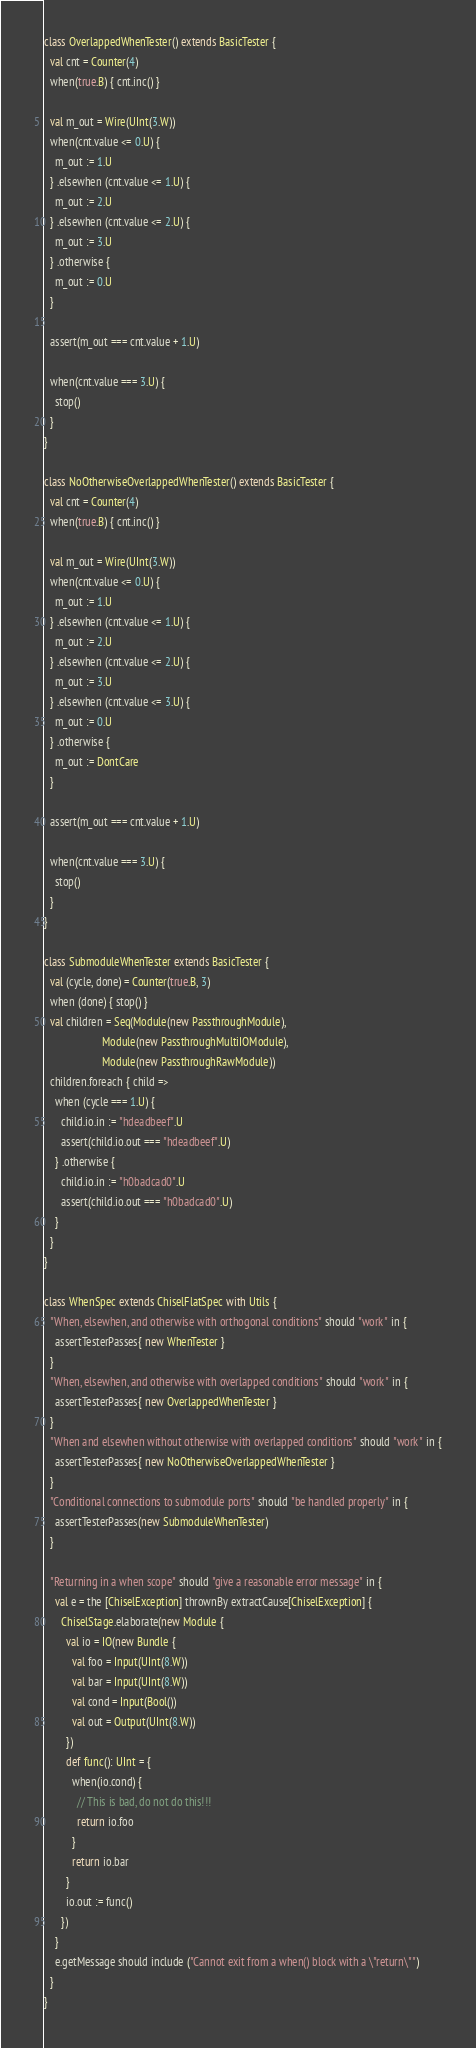Convert code to text. <code><loc_0><loc_0><loc_500><loc_500><_Scala_>
class OverlappedWhenTester() extends BasicTester {
  val cnt = Counter(4)
  when(true.B) { cnt.inc() }

  val m_out = Wire(UInt(3.W))
  when(cnt.value <= 0.U) {
    m_out := 1.U
  } .elsewhen (cnt.value <= 1.U) {
    m_out := 2.U
  } .elsewhen (cnt.value <= 2.U) {
    m_out := 3.U
  } .otherwise {
    m_out := 0.U
  }

  assert(m_out === cnt.value + 1.U)

  when(cnt.value === 3.U) {
    stop()
  }
}

class NoOtherwiseOverlappedWhenTester() extends BasicTester {
  val cnt = Counter(4)
  when(true.B) { cnt.inc() }

  val m_out = Wire(UInt(3.W))
  when(cnt.value <= 0.U) {
    m_out := 1.U
  } .elsewhen (cnt.value <= 1.U) {
    m_out := 2.U
  } .elsewhen (cnt.value <= 2.U) {
    m_out := 3.U
  } .elsewhen (cnt.value <= 3.U) {
    m_out := 0.U
  } .otherwise {
    m_out := DontCare
  }

  assert(m_out === cnt.value + 1.U)

  when(cnt.value === 3.U) {
    stop()
  }
}

class SubmoduleWhenTester extends BasicTester {
  val (cycle, done) = Counter(true.B, 3)
  when (done) { stop() }
  val children = Seq(Module(new PassthroughModule),
                     Module(new PassthroughMultiIOModule),
                     Module(new PassthroughRawModule))
  children.foreach { child =>
    when (cycle === 1.U) {
      child.io.in := "hdeadbeef".U
      assert(child.io.out === "hdeadbeef".U)
    } .otherwise {
      child.io.in := "h0badcad0".U
      assert(child.io.out === "h0badcad0".U)
    }
  }
}

class WhenSpec extends ChiselFlatSpec with Utils {
  "When, elsewhen, and otherwise with orthogonal conditions" should "work" in {
    assertTesterPasses{ new WhenTester }
  }
  "When, elsewhen, and otherwise with overlapped conditions" should "work" in {
    assertTesterPasses{ new OverlappedWhenTester }
  }
  "When and elsewhen without otherwise with overlapped conditions" should "work" in {
    assertTesterPasses{ new NoOtherwiseOverlappedWhenTester }
  }
  "Conditional connections to submodule ports" should "be handled properly" in {
    assertTesterPasses(new SubmoduleWhenTester)
  }

  "Returning in a when scope" should "give a reasonable error message" in {
    val e = the [ChiselException] thrownBy extractCause[ChiselException] {
      ChiselStage.elaborate(new Module {
        val io = IO(new Bundle {
          val foo = Input(UInt(8.W))
          val bar = Input(UInt(8.W))
          val cond = Input(Bool())
          val out = Output(UInt(8.W))
        })
        def func(): UInt = {
          when(io.cond) {
            // This is bad, do not do this!!!
            return io.foo
          }
          return io.bar
        }
        io.out := func()
      })
    }
    e.getMessage should include ("Cannot exit from a when() block with a \"return\"")
  }
}
</code> 